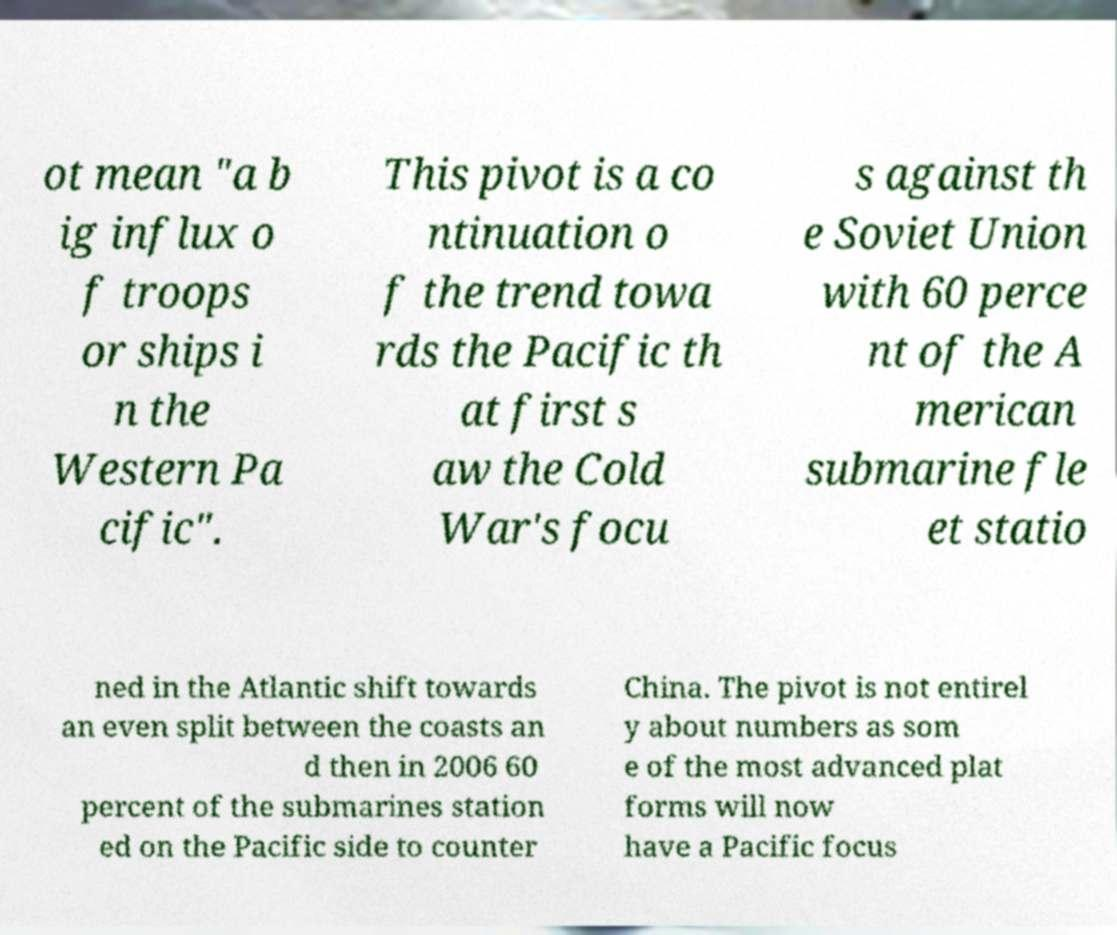Can you read and provide the text displayed in the image?This photo seems to have some interesting text. Can you extract and type it out for me? ot mean "a b ig influx o f troops or ships i n the Western Pa cific". This pivot is a co ntinuation o f the trend towa rds the Pacific th at first s aw the Cold War's focu s against th e Soviet Union with 60 perce nt of the A merican submarine fle et statio ned in the Atlantic shift towards an even split between the coasts an d then in 2006 60 percent of the submarines station ed on the Pacific side to counter China. The pivot is not entirel y about numbers as som e of the most advanced plat forms will now have a Pacific focus 